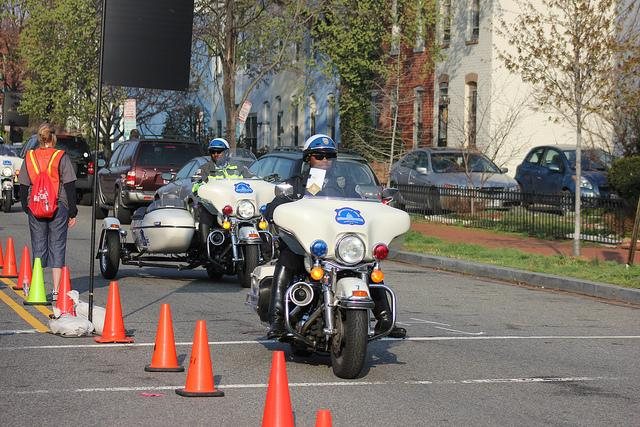What is the use of the following traffic cones?

Choices:
A) block road
B) stop vehicle
C) decoration
D) traffic redirection traffic redirection 